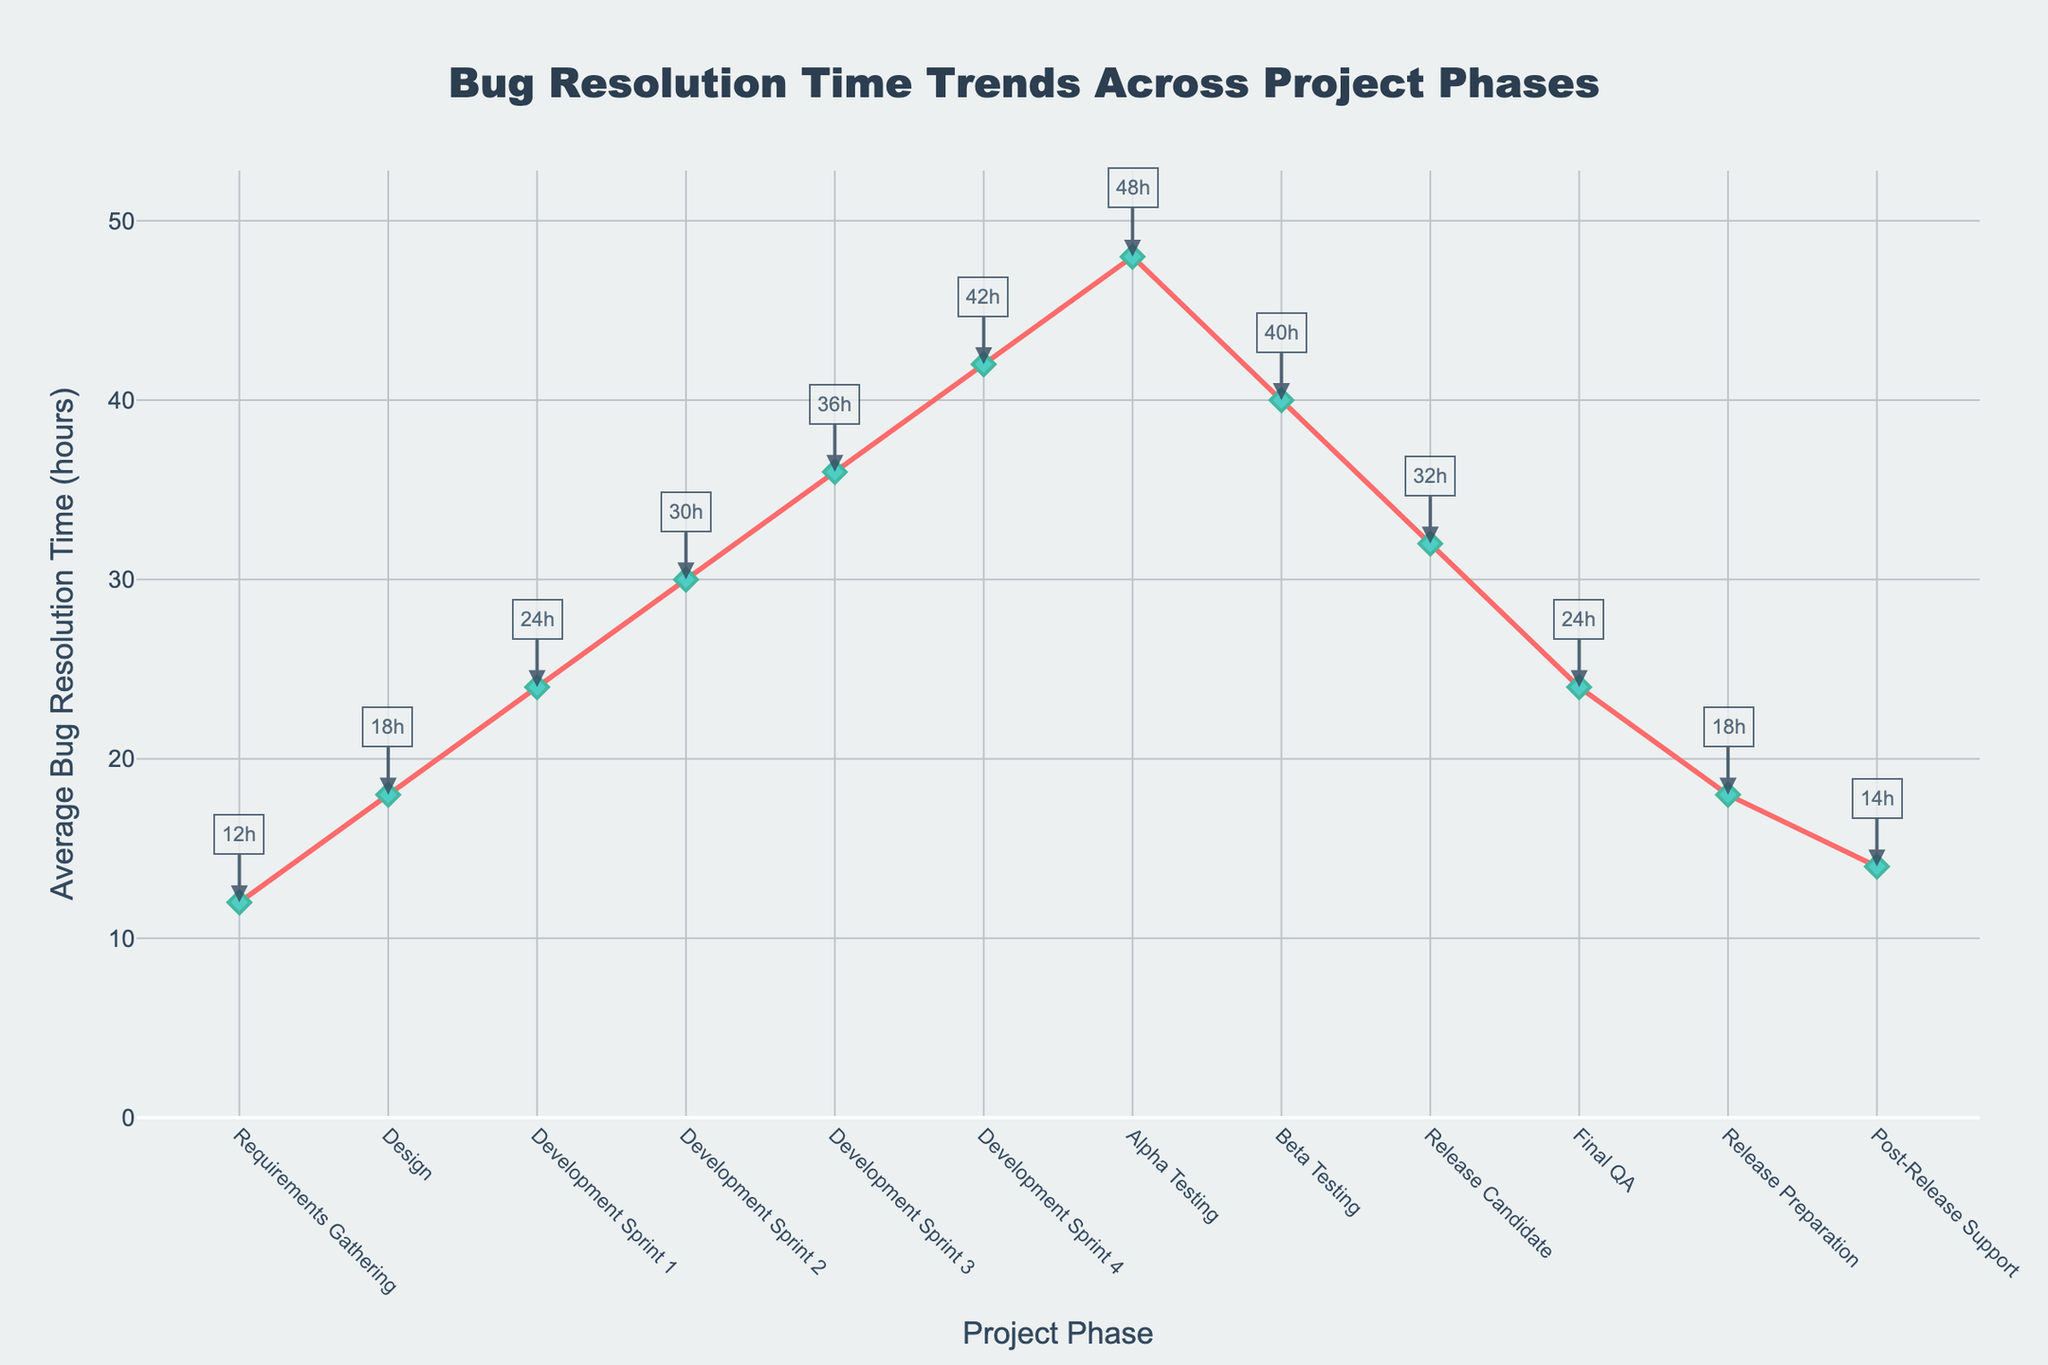What project phase has the highest average bug resolution time? First, look for the phase with the highest point on the y-axis. From the figure, the highest average bug resolution time is during the Alpha Testing phase, reaching 48 hours.
Answer: Alpha Testing By how many hours does the average bug resolution time during Beta Testing exceed that during Release Candidate? Note that the average bug resolution time for Beta Testing is 40 hours and for Release Candidate it is 32 hours. Calculate the difference: 40 - 32 = 8 hours.
Answer: 8 Which project phase shows the quickest average bug resolution time? Identify the phase with the lowest point on the y-axis. The phase with the quickest average bug resolution time is Requirements Gathering, with 12 hours.
Answer: Requirements Gathering What is the total average bug resolution time from Development Sprint 1 to Development Sprint 4? Sum the average bug resolution times of the four phases: Development Sprint 1 (24), Development Sprint 2 (30), Development Sprint 3 (36), and Development Sprint 4 (42). Calculation: 24 + 30 + 36 + 42 = 132 hours.
Answer: 132 By what percentage does the average bug resolution time decrease from Alpha Testing to Post-Release Support? Calculate the difference in time between Alpha Testing (48 hours) and Post-Release Support (14 hours): 48 - 14 = 34 hours. Then, divide this difference by the Alpha Testing time and multiply by 100 to find the percentage: (34/48) * 100 ≈ 70.83%.
Answer: 70.83 Identify a phase where the average bug resolution time decreases compared to the previous phase. The average bug resolution time decreases from Alpha Testing (48 hours) to Beta Testing (40 hours).
Answer: Beta Testing Which phase shows an equal average bug resolution time compared to the Final QA phase? Identify the phase with the same point on the y-axis as Final QA. The average bug resolution time for Final QA is 24 hours. The Development Sprint 1 phase also shows an average bug resolution time of 24 hours.
Answer: Development Sprint 1 What is the combined time for the phases with the highest and lowest average bug resolution times? Add the times of the highest (Alpha Testing at 48 hours) and lowest (Requirements Gathering at 12 hours) average bug resolution times: 48 + 12 = 60 hours.
Answer: 60 How much does the average bug resolution time change from Release Candidate to Final QA? Determine the difference between Release Candidate (32 hours) and Final QA (24 hours): 32 - 24 = 8 hours.
Answer: 8 Between which two consecutive phases is the largest increase in average bug resolution time observed? Compare the differences between each pair of consecutive phases: Requirements Gathering to Design (6 hours), Design to Development Sprint 1 (6 hours), Development Sprint 1 to Development Sprint 2 (6 hours), Development Sprint 2 to Development Sprint 3 (6 hours), Development Sprint 3 to Development Sprint 4 (6 hours), Development Sprint 4 to Alpha Testing (6 hours), Alpha Testing to Beta Testing (-8 hours), Beta Testing to Release Candidate (-8 hours), Release Candidate to Final QA (-8 hours), Final QA to Release Preparation (-6 hours), Release Preparation to Post-Release Support (-4 hours). The largest positive change is from Development Sprint 3 to Development Sprint 4, by 6 hours.
Answer: Development Sprint 3 to Development Sprint 4 